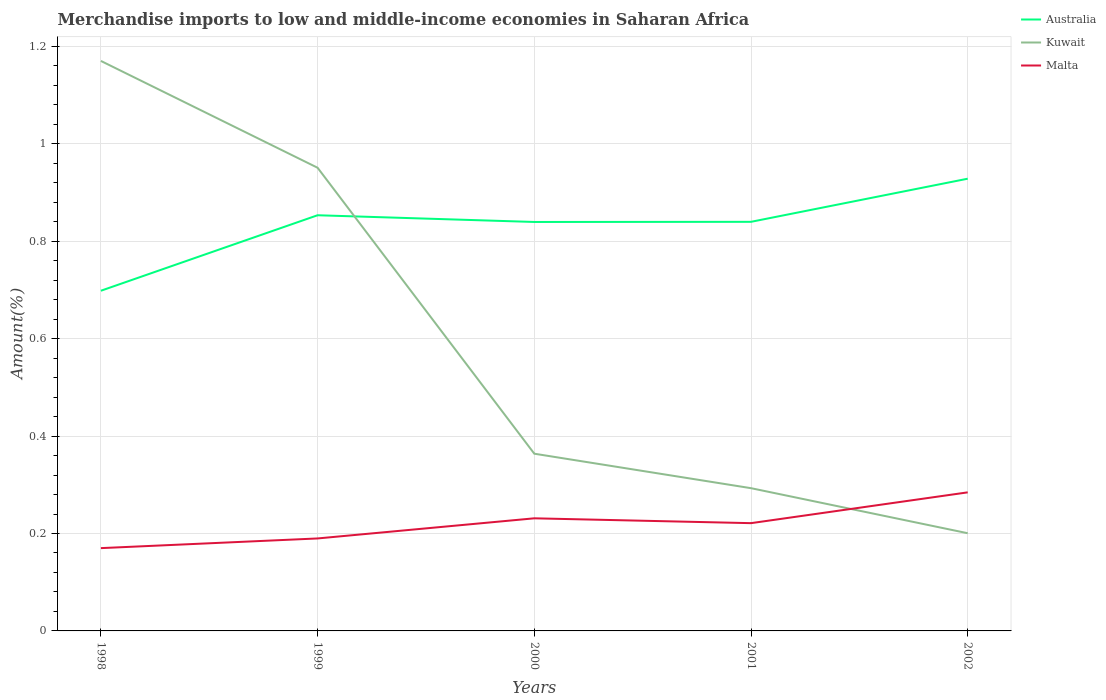Is the number of lines equal to the number of legend labels?
Your response must be concise. Yes. Across all years, what is the maximum percentage of amount earned from merchandise imports in Malta?
Provide a succinct answer. 0.17. What is the total percentage of amount earned from merchandise imports in Australia in the graph?
Ensure brevity in your answer.  0.01. What is the difference between the highest and the second highest percentage of amount earned from merchandise imports in Malta?
Make the answer very short. 0.11. What is the difference between the highest and the lowest percentage of amount earned from merchandise imports in Malta?
Your answer should be very brief. 3. What is the difference between two consecutive major ticks on the Y-axis?
Provide a succinct answer. 0.2. Does the graph contain grids?
Provide a short and direct response. Yes. How many legend labels are there?
Ensure brevity in your answer.  3. How are the legend labels stacked?
Your answer should be compact. Vertical. What is the title of the graph?
Offer a very short reply. Merchandise imports to low and middle-income economies in Saharan Africa. What is the label or title of the Y-axis?
Offer a very short reply. Amount(%). What is the Amount(%) in Australia in 1998?
Keep it short and to the point. 0.7. What is the Amount(%) in Kuwait in 1998?
Your response must be concise. 1.17. What is the Amount(%) in Malta in 1998?
Your response must be concise. 0.17. What is the Amount(%) in Australia in 1999?
Your response must be concise. 0.85. What is the Amount(%) of Kuwait in 1999?
Provide a succinct answer. 0.95. What is the Amount(%) in Malta in 1999?
Keep it short and to the point. 0.19. What is the Amount(%) in Australia in 2000?
Make the answer very short. 0.84. What is the Amount(%) in Kuwait in 2000?
Offer a very short reply. 0.36. What is the Amount(%) in Malta in 2000?
Offer a very short reply. 0.23. What is the Amount(%) of Australia in 2001?
Your answer should be very brief. 0.84. What is the Amount(%) in Kuwait in 2001?
Your response must be concise. 0.29. What is the Amount(%) in Malta in 2001?
Your response must be concise. 0.22. What is the Amount(%) of Australia in 2002?
Your response must be concise. 0.93. What is the Amount(%) of Kuwait in 2002?
Ensure brevity in your answer.  0.2. What is the Amount(%) in Malta in 2002?
Keep it short and to the point. 0.28. Across all years, what is the maximum Amount(%) of Australia?
Your answer should be very brief. 0.93. Across all years, what is the maximum Amount(%) of Kuwait?
Make the answer very short. 1.17. Across all years, what is the maximum Amount(%) of Malta?
Give a very brief answer. 0.28. Across all years, what is the minimum Amount(%) in Australia?
Provide a short and direct response. 0.7. Across all years, what is the minimum Amount(%) of Kuwait?
Provide a succinct answer. 0.2. Across all years, what is the minimum Amount(%) of Malta?
Provide a short and direct response. 0.17. What is the total Amount(%) in Australia in the graph?
Provide a succinct answer. 4.16. What is the total Amount(%) of Kuwait in the graph?
Keep it short and to the point. 2.98. What is the total Amount(%) of Malta in the graph?
Provide a succinct answer. 1.1. What is the difference between the Amount(%) of Australia in 1998 and that in 1999?
Offer a terse response. -0.15. What is the difference between the Amount(%) of Kuwait in 1998 and that in 1999?
Your answer should be compact. 0.22. What is the difference between the Amount(%) of Malta in 1998 and that in 1999?
Offer a very short reply. -0.02. What is the difference between the Amount(%) in Australia in 1998 and that in 2000?
Provide a short and direct response. -0.14. What is the difference between the Amount(%) in Kuwait in 1998 and that in 2000?
Offer a very short reply. 0.81. What is the difference between the Amount(%) in Malta in 1998 and that in 2000?
Ensure brevity in your answer.  -0.06. What is the difference between the Amount(%) in Australia in 1998 and that in 2001?
Provide a succinct answer. -0.14. What is the difference between the Amount(%) of Kuwait in 1998 and that in 2001?
Provide a short and direct response. 0.88. What is the difference between the Amount(%) in Malta in 1998 and that in 2001?
Give a very brief answer. -0.05. What is the difference between the Amount(%) of Australia in 1998 and that in 2002?
Offer a terse response. -0.23. What is the difference between the Amount(%) in Kuwait in 1998 and that in 2002?
Offer a very short reply. 0.97. What is the difference between the Amount(%) of Malta in 1998 and that in 2002?
Provide a succinct answer. -0.11. What is the difference between the Amount(%) in Australia in 1999 and that in 2000?
Provide a succinct answer. 0.01. What is the difference between the Amount(%) of Kuwait in 1999 and that in 2000?
Keep it short and to the point. 0.59. What is the difference between the Amount(%) of Malta in 1999 and that in 2000?
Offer a terse response. -0.04. What is the difference between the Amount(%) in Australia in 1999 and that in 2001?
Provide a succinct answer. 0.01. What is the difference between the Amount(%) in Kuwait in 1999 and that in 2001?
Give a very brief answer. 0.66. What is the difference between the Amount(%) of Malta in 1999 and that in 2001?
Offer a very short reply. -0.03. What is the difference between the Amount(%) of Australia in 1999 and that in 2002?
Give a very brief answer. -0.07. What is the difference between the Amount(%) in Kuwait in 1999 and that in 2002?
Provide a short and direct response. 0.75. What is the difference between the Amount(%) in Malta in 1999 and that in 2002?
Ensure brevity in your answer.  -0.09. What is the difference between the Amount(%) of Australia in 2000 and that in 2001?
Give a very brief answer. -0. What is the difference between the Amount(%) in Kuwait in 2000 and that in 2001?
Offer a terse response. 0.07. What is the difference between the Amount(%) of Malta in 2000 and that in 2001?
Keep it short and to the point. 0.01. What is the difference between the Amount(%) of Australia in 2000 and that in 2002?
Offer a very short reply. -0.09. What is the difference between the Amount(%) in Kuwait in 2000 and that in 2002?
Offer a terse response. 0.16. What is the difference between the Amount(%) of Malta in 2000 and that in 2002?
Provide a succinct answer. -0.05. What is the difference between the Amount(%) of Australia in 2001 and that in 2002?
Give a very brief answer. -0.09. What is the difference between the Amount(%) of Kuwait in 2001 and that in 2002?
Your answer should be very brief. 0.09. What is the difference between the Amount(%) of Malta in 2001 and that in 2002?
Offer a terse response. -0.06. What is the difference between the Amount(%) of Australia in 1998 and the Amount(%) of Kuwait in 1999?
Provide a succinct answer. -0.25. What is the difference between the Amount(%) of Australia in 1998 and the Amount(%) of Malta in 1999?
Your response must be concise. 0.51. What is the difference between the Amount(%) in Kuwait in 1998 and the Amount(%) in Malta in 1999?
Make the answer very short. 0.98. What is the difference between the Amount(%) of Australia in 1998 and the Amount(%) of Kuwait in 2000?
Provide a short and direct response. 0.33. What is the difference between the Amount(%) in Australia in 1998 and the Amount(%) in Malta in 2000?
Provide a succinct answer. 0.47. What is the difference between the Amount(%) of Kuwait in 1998 and the Amount(%) of Malta in 2000?
Offer a terse response. 0.94. What is the difference between the Amount(%) in Australia in 1998 and the Amount(%) in Kuwait in 2001?
Offer a terse response. 0.41. What is the difference between the Amount(%) in Australia in 1998 and the Amount(%) in Malta in 2001?
Your answer should be very brief. 0.48. What is the difference between the Amount(%) in Kuwait in 1998 and the Amount(%) in Malta in 2001?
Make the answer very short. 0.95. What is the difference between the Amount(%) in Australia in 1998 and the Amount(%) in Kuwait in 2002?
Offer a terse response. 0.5. What is the difference between the Amount(%) of Australia in 1998 and the Amount(%) of Malta in 2002?
Ensure brevity in your answer.  0.41. What is the difference between the Amount(%) of Kuwait in 1998 and the Amount(%) of Malta in 2002?
Ensure brevity in your answer.  0.89. What is the difference between the Amount(%) in Australia in 1999 and the Amount(%) in Kuwait in 2000?
Your answer should be compact. 0.49. What is the difference between the Amount(%) in Australia in 1999 and the Amount(%) in Malta in 2000?
Your response must be concise. 0.62. What is the difference between the Amount(%) of Kuwait in 1999 and the Amount(%) of Malta in 2000?
Your answer should be compact. 0.72. What is the difference between the Amount(%) in Australia in 1999 and the Amount(%) in Kuwait in 2001?
Provide a short and direct response. 0.56. What is the difference between the Amount(%) in Australia in 1999 and the Amount(%) in Malta in 2001?
Make the answer very short. 0.63. What is the difference between the Amount(%) in Kuwait in 1999 and the Amount(%) in Malta in 2001?
Give a very brief answer. 0.73. What is the difference between the Amount(%) in Australia in 1999 and the Amount(%) in Kuwait in 2002?
Ensure brevity in your answer.  0.65. What is the difference between the Amount(%) of Australia in 1999 and the Amount(%) of Malta in 2002?
Provide a succinct answer. 0.57. What is the difference between the Amount(%) of Kuwait in 1999 and the Amount(%) of Malta in 2002?
Offer a terse response. 0.67. What is the difference between the Amount(%) in Australia in 2000 and the Amount(%) in Kuwait in 2001?
Keep it short and to the point. 0.55. What is the difference between the Amount(%) in Australia in 2000 and the Amount(%) in Malta in 2001?
Ensure brevity in your answer.  0.62. What is the difference between the Amount(%) in Kuwait in 2000 and the Amount(%) in Malta in 2001?
Your response must be concise. 0.14. What is the difference between the Amount(%) in Australia in 2000 and the Amount(%) in Kuwait in 2002?
Ensure brevity in your answer.  0.64. What is the difference between the Amount(%) in Australia in 2000 and the Amount(%) in Malta in 2002?
Make the answer very short. 0.56. What is the difference between the Amount(%) of Kuwait in 2000 and the Amount(%) of Malta in 2002?
Offer a very short reply. 0.08. What is the difference between the Amount(%) in Australia in 2001 and the Amount(%) in Kuwait in 2002?
Your answer should be compact. 0.64. What is the difference between the Amount(%) in Australia in 2001 and the Amount(%) in Malta in 2002?
Make the answer very short. 0.56. What is the difference between the Amount(%) in Kuwait in 2001 and the Amount(%) in Malta in 2002?
Offer a terse response. 0.01. What is the average Amount(%) in Australia per year?
Offer a very short reply. 0.83. What is the average Amount(%) in Kuwait per year?
Give a very brief answer. 0.6. What is the average Amount(%) in Malta per year?
Provide a succinct answer. 0.22. In the year 1998, what is the difference between the Amount(%) in Australia and Amount(%) in Kuwait?
Your response must be concise. -0.47. In the year 1998, what is the difference between the Amount(%) in Australia and Amount(%) in Malta?
Keep it short and to the point. 0.53. In the year 1999, what is the difference between the Amount(%) of Australia and Amount(%) of Kuwait?
Your answer should be very brief. -0.1. In the year 1999, what is the difference between the Amount(%) in Australia and Amount(%) in Malta?
Ensure brevity in your answer.  0.66. In the year 1999, what is the difference between the Amount(%) in Kuwait and Amount(%) in Malta?
Offer a very short reply. 0.76. In the year 2000, what is the difference between the Amount(%) of Australia and Amount(%) of Kuwait?
Your answer should be very brief. 0.48. In the year 2000, what is the difference between the Amount(%) in Australia and Amount(%) in Malta?
Ensure brevity in your answer.  0.61. In the year 2000, what is the difference between the Amount(%) of Kuwait and Amount(%) of Malta?
Your answer should be compact. 0.13. In the year 2001, what is the difference between the Amount(%) in Australia and Amount(%) in Kuwait?
Give a very brief answer. 0.55. In the year 2001, what is the difference between the Amount(%) of Australia and Amount(%) of Malta?
Your response must be concise. 0.62. In the year 2001, what is the difference between the Amount(%) of Kuwait and Amount(%) of Malta?
Ensure brevity in your answer.  0.07. In the year 2002, what is the difference between the Amount(%) of Australia and Amount(%) of Kuwait?
Keep it short and to the point. 0.73. In the year 2002, what is the difference between the Amount(%) of Australia and Amount(%) of Malta?
Make the answer very short. 0.64. In the year 2002, what is the difference between the Amount(%) in Kuwait and Amount(%) in Malta?
Make the answer very short. -0.08. What is the ratio of the Amount(%) of Australia in 1998 to that in 1999?
Your answer should be compact. 0.82. What is the ratio of the Amount(%) of Kuwait in 1998 to that in 1999?
Your answer should be compact. 1.23. What is the ratio of the Amount(%) of Malta in 1998 to that in 1999?
Offer a terse response. 0.9. What is the ratio of the Amount(%) in Australia in 1998 to that in 2000?
Ensure brevity in your answer.  0.83. What is the ratio of the Amount(%) in Kuwait in 1998 to that in 2000?
Offer a terse response. 3.22. What is the ratio of the Amount(%) of Malta in 1998 to that in 2000?
Provide a succinct answer. 0.74. What is the ratio of the Amount(%) of Australia in 1998 to that in 2001?
Ensure brevity in your answer.  0.83. What is the ratio of the Amount(%) in Kuwait in 1998 to that in 2001?
Provide a succinct answer. 3.99. What is the ratio of the Amount(%) in Malta in 1998 to that in 2001?
Your response must be concise. 0.77. What is the ratio of the Amount(%) of Australia in 1998 to that in 2002?
Offer a terse response. 0.75. What is the ratio of the Amount(%) of Kuwait in 1998 to that in 2002?
Keep it short and to the point. 5.83. What is the ratio of the Amount(%) in Malta in 1998 to that in 2002?
Your answer should be very brief. 0.6. What is the ratio of the Amount(%) of Australia in 1999 to that in 2000?
Your response must be concise. 1.02. What is the ratio of the Amount(%) in Kuwait in 1999 to that in 2000?
Give a very brief answer. 2.61. What is the ratio of the Amount(%) in Malta in 1999 to that in 2000?
Provide a succinct answer. 0.82. What is the ratio of the Amount(%) in Australia in 1999 to that in 2001?
Provide a succinct answer. 1.02. What is the ratio of the Amount(%) in Kuwait in 1999 to that in 2001?
Give a very brief answer. 3.24. What is the ratio of the Amount(%) in Malta in 1999 to that in 2001?
Your response must be concise. 0.86. What is the ratio of the Amount(%) of Australia in 1999 to that in 2002?
Give a very brief answer. 0.92. What is the ratio of the Amount(%) in Kuwait in 1999 to that in 2002?
Provide a short and direct response. 4.74. What is the ratio of the Amount(%) in Malta in 1999 to that in 2002?
Make the answer very short. 0.67. What is the ratio of the Amount(%) in Australia in 2000 to that in 2001?
Provide a succinct answer. 1. What is the ratio of the Amount(%) in Kuwait in 2000 to that in 2001?
Your answer should be very brief. 1.24. What is the ratio of the Amount(%) in Malta in 2000 to that in 2001?
Give a very brief answer. 1.04. What is the ratio of the Amount(%) of Australia in 2000 to that in 2002?
Your answer should be very brief. 0.9. What is the ratio of the Amount(%) of Kuwait in 2000 to that in 2002?
Your response must be concise. 1.81. What is the ratio of the Amount(%) in Malta in 2000 to that in 2002?
Ensure brevity in your answer.  0.81. What is the ratio of the Amount(%) of Australia in 2001 to that in 2002?
Your answer should be very brief. 0.9. What is the ratio of the Amount(%) in Kuwait in 2001 to that in 2002?
Your answer should be very brief. 1.46. What is the ratio of the Amount(%) in Malta in 2001 to that in 2002?
Make the answer very short. 0.78. What is the difference between the highest and the second highest Amount(%) in Australia?
Offer a terse response. 0.07. What is the difference between the highest and the second highest Amount(%) in Kuwait?
Provide a short and direct response. 0.22. What is the difference between the highest and the second highest Amount(%) of Malta?
Offer a terse response. 0.05. What is the difference between the highest and the lowest Amount(%) of Australia?
Your answer should be compact. 0.23. What is the difference between the highest and the lowest Amount(%) in Kuwait?
Offer a terse response. 0.97. What is the difference between the highest and the lowest Amount(%) of Malta?
Make the answer very short. 0.11. 